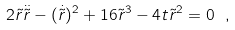Convert formula to latex. <formula><loc_0><loc_0><loc_500><loc_500>2 \tilde { r } \ddot { \tilde { r } } - ( \dot { \tilde { r } } ) ^ { 2 } + 1 6 \tilde { r } ^ { 3 } - 4 t \tilde { r } ^ { 2 } = 0 \ ,</formula> 